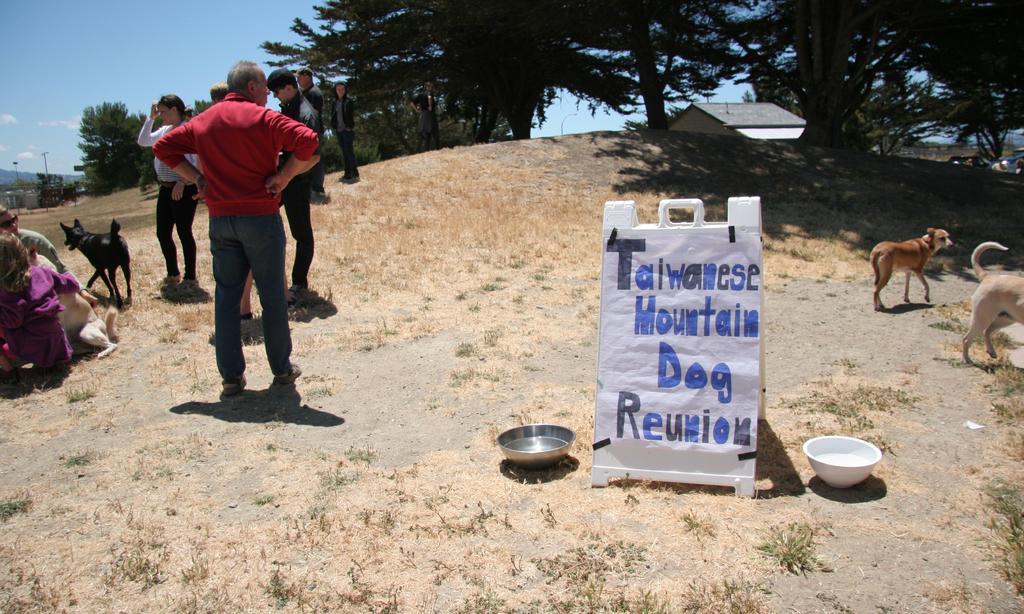Describe this image in one or two sentences. In this picture we can see some persons are standing. There is a dog and these are the trees. Here we can see two bowls. And there is a sky. 